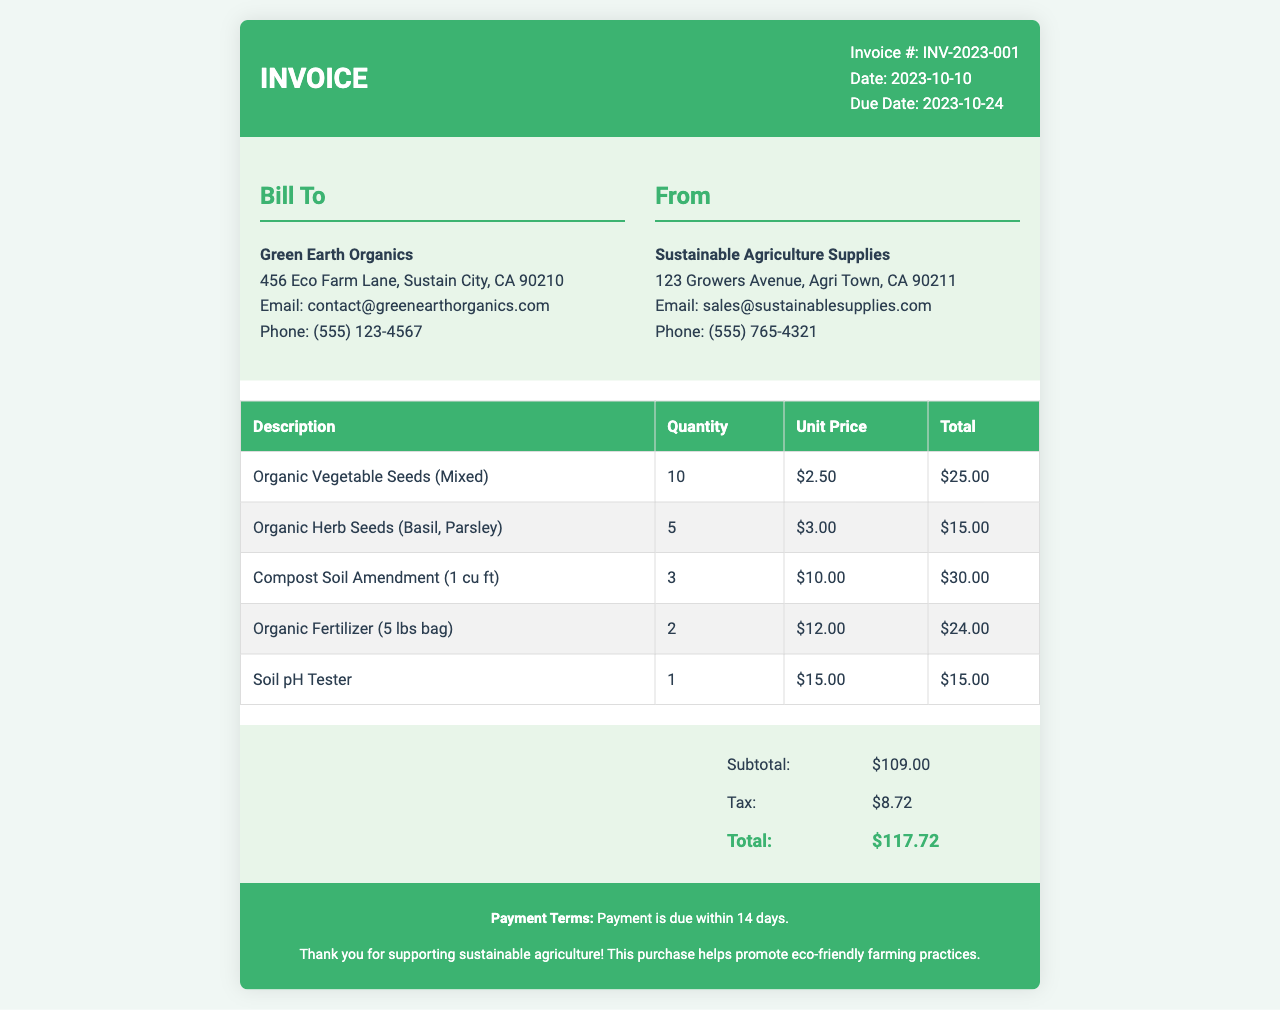What is the invoice number? The invoice number is listed at the top of the document for reference.
Answer: INV-2023-001 What is the date of the invoice? The date of the invoice is specified in the invoice details section.
Answer: 2023-10-10 Who is the seller? The seller's name is provided in the "From" section, indicating who issued the invoice.
Answer: Sustainable Agriculture Supplies How many units of Organic Vegetable Seeds were purchased? The quantity for each item is listed in the items table.
Answer: 10 What is the unit price of the Soil pH Tester? The unit price is provided alongside the description of the item in the invoice.
Answer: $15.00 What is the subtotal amount? The subtotal is a summarized figure before tax is applied, clearly shown in the summary section.
Answer: $109.00 What is the total cost including tax? The total is the final amount including all items, subtotal, and tax listed in the summary table.
Answer: $117.72 Which item has the highest unit price? By comparing all unit prices in the items table, one can infer which is the highest.
Answer: Compost Soil Amendment What is the payment term for this invoice? The payment terms are described at the bottom of the invoice to inform the buyer.
Answer: Payment is due within 14 days How many different types of seeds were listed in the invoice? Counting the different seed types mentioned in the items table indicates the variety offered.
Answer: 2 